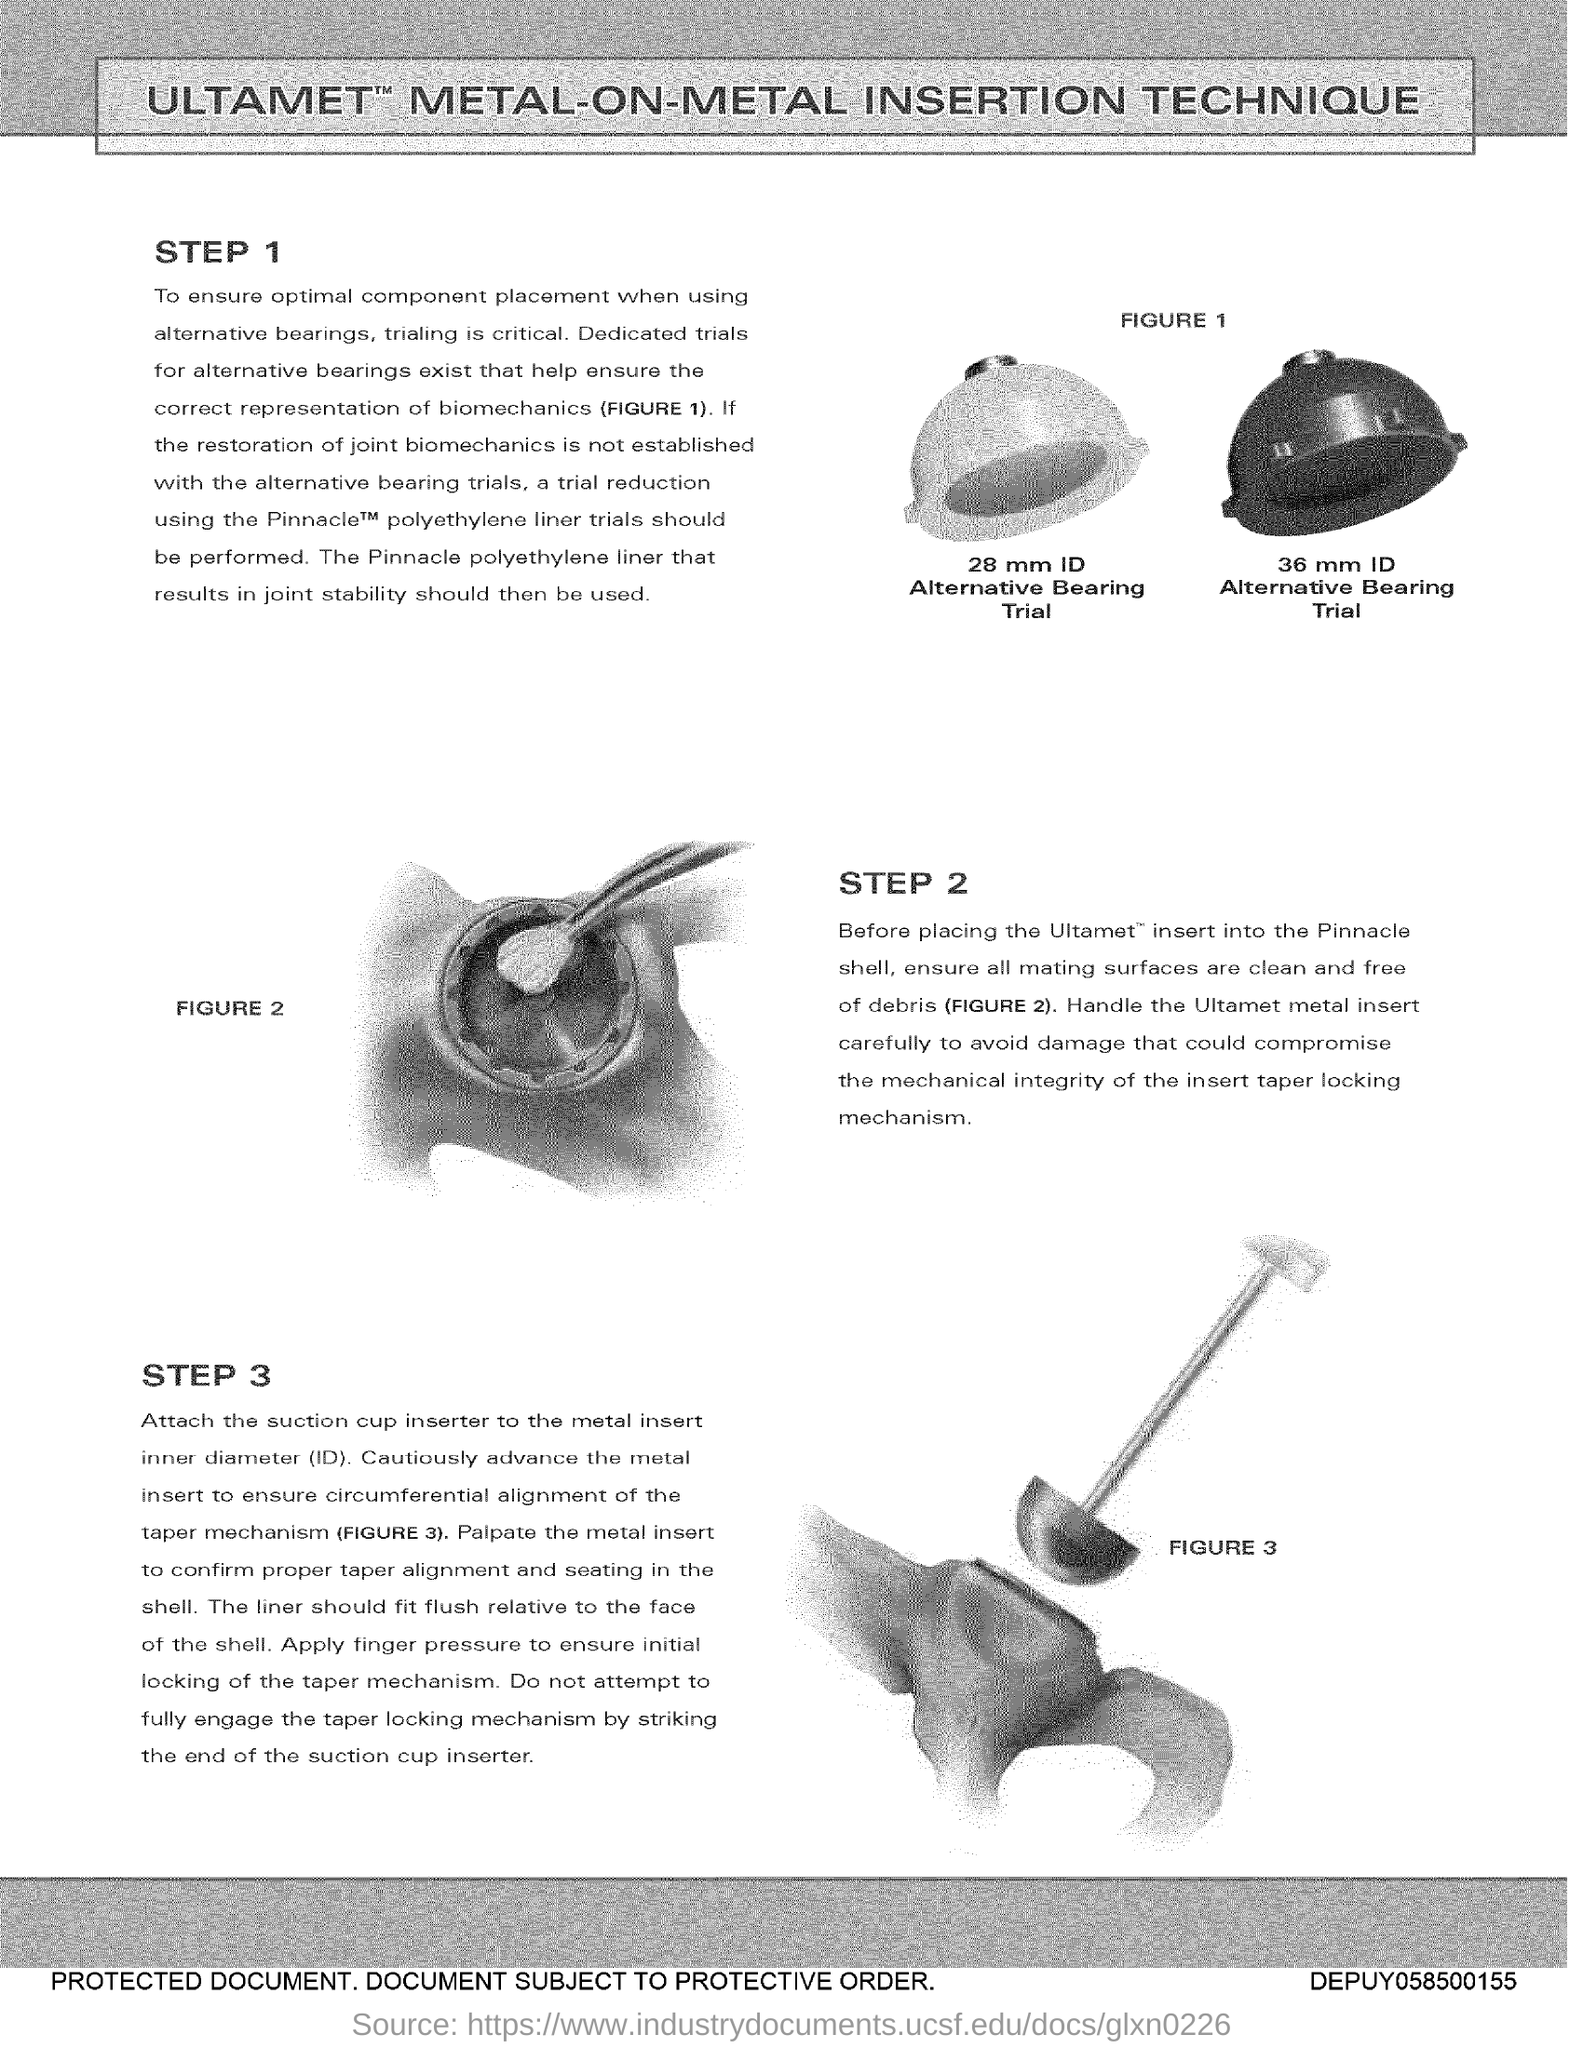What is the heading of the document?
Your answer should be compact. Ultamet metal-on-metal insertion technique. How many steps are involved in the procedure?
Your response must be concise. 3. 